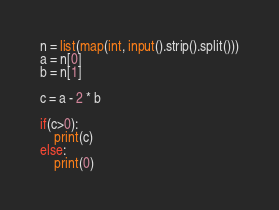<code> <loc_0><loc_0><loc_500><loc_500><_Python_>n = list(map(int, input().strip().split()))
a = n[0]
b = n[1]

c = a - 2 * b

if(c>0):
    print(c)
else:
    print(0)
</code> 